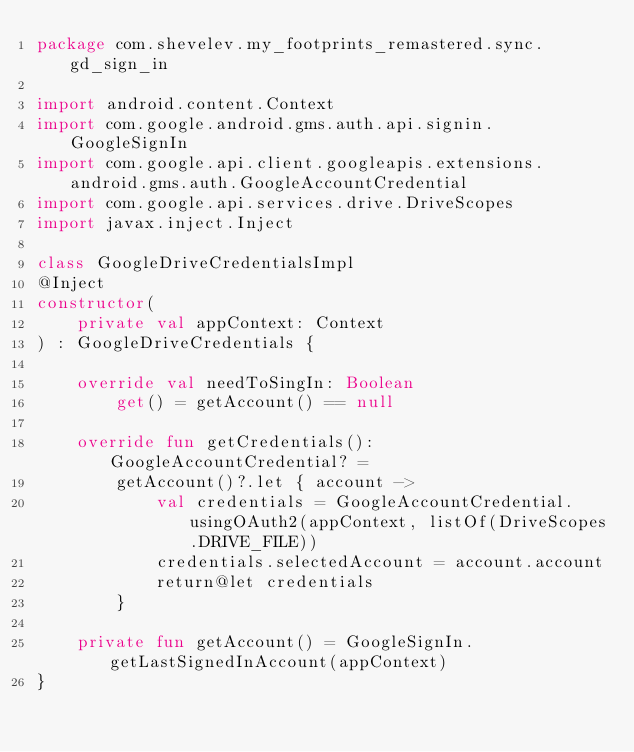Convert code to text. <code><loc_0><loc_0><loc_500><loc_500><_Kotlin_>package com.shevelev.my_footprints_remastered.sync.gd_sign_in

import android.content.Context
import com.google.android.gms.auth.api.signin.GoogleSignIn
import com.google.api.client.googleapis.extensions.android.gms.auth.GoogleAccountCredential
import com.google.api.services.drive.DriveScopes
import javax.inject.Inject

class GoogleDriveCredentialsImpl
@Inject
constructor(
    private val appContext: Context
) : GoogleDriveCredentials {

    override val needToSingIn: Boolean
        get() = getAccount() == null

    override fun getCredentials(): GoogleAccountCredential? =
        getAccount()?.let { account ->
            val credentials = GoogleAccountCredential.usingOAuth2(appContext, listOf(DriveScopes.DRIVE_FILE))
            credentials.selectedAccount = account.account
            return@let credentials
        }

    private fun getAccount() = GoogleSignIn.getLastSignedInAccount(appContext)
}</code> 